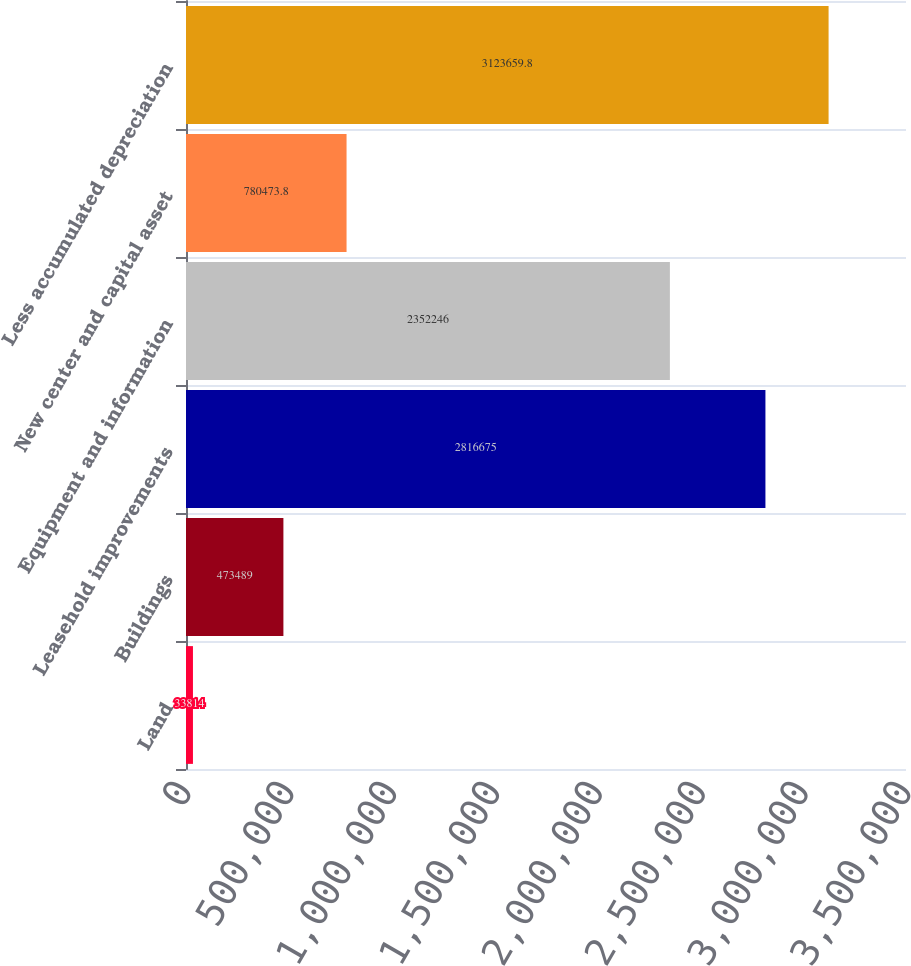<chart> <loc_0><loc_0><loc_500><loc_500><bar_chart><fcel>Land<fcel>Buildings<fcel>Leasehold improvements<fcel>Equipment and information<fcel>New center and capital asset<fcel>Less accumulated depreciation<nl><fcel>33814<fcel>473489<fcel>2.81668e+06<fcel>2.35225e+06<fcel>780474<fcel>3.12366e+06<nl></chart> 